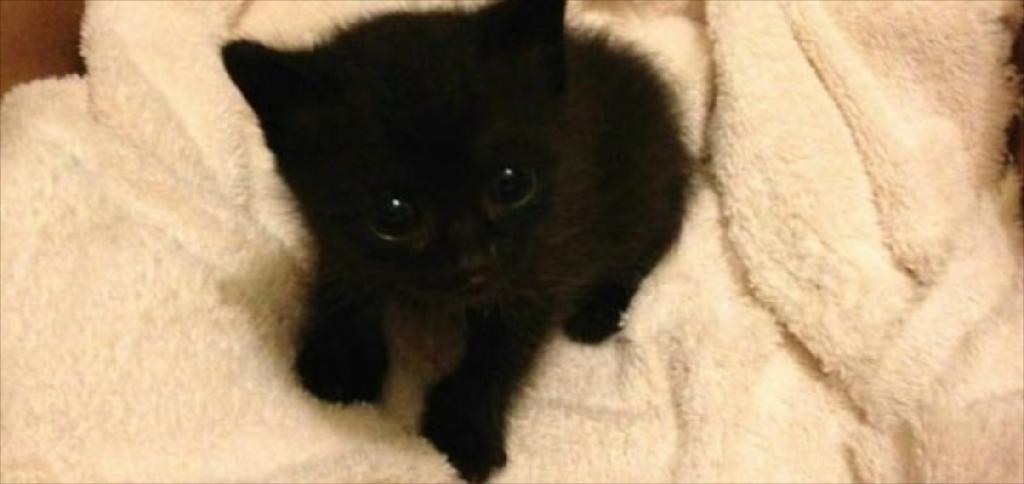Please provide a concise description of this image. In this image, we can see an animal on the white cloth. 